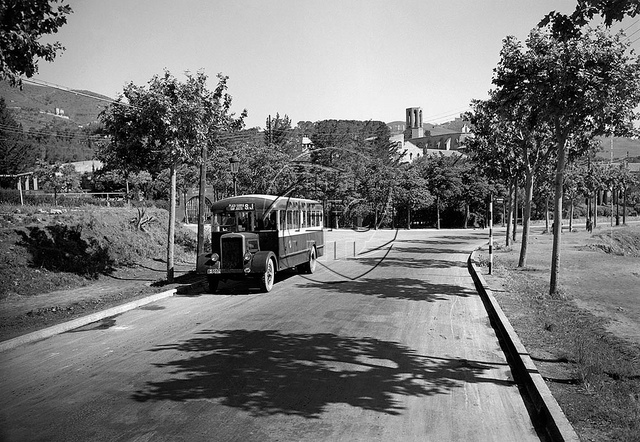<image>How old is this bus? It is unknown how old this bus is. How old is this bus? I don't know how old this bus is. It can be seen as old, very old or even 100 years old. 